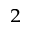<formula> <loc_0><loc_0><loc_500><loc_500>^ { 2 }</formula> 